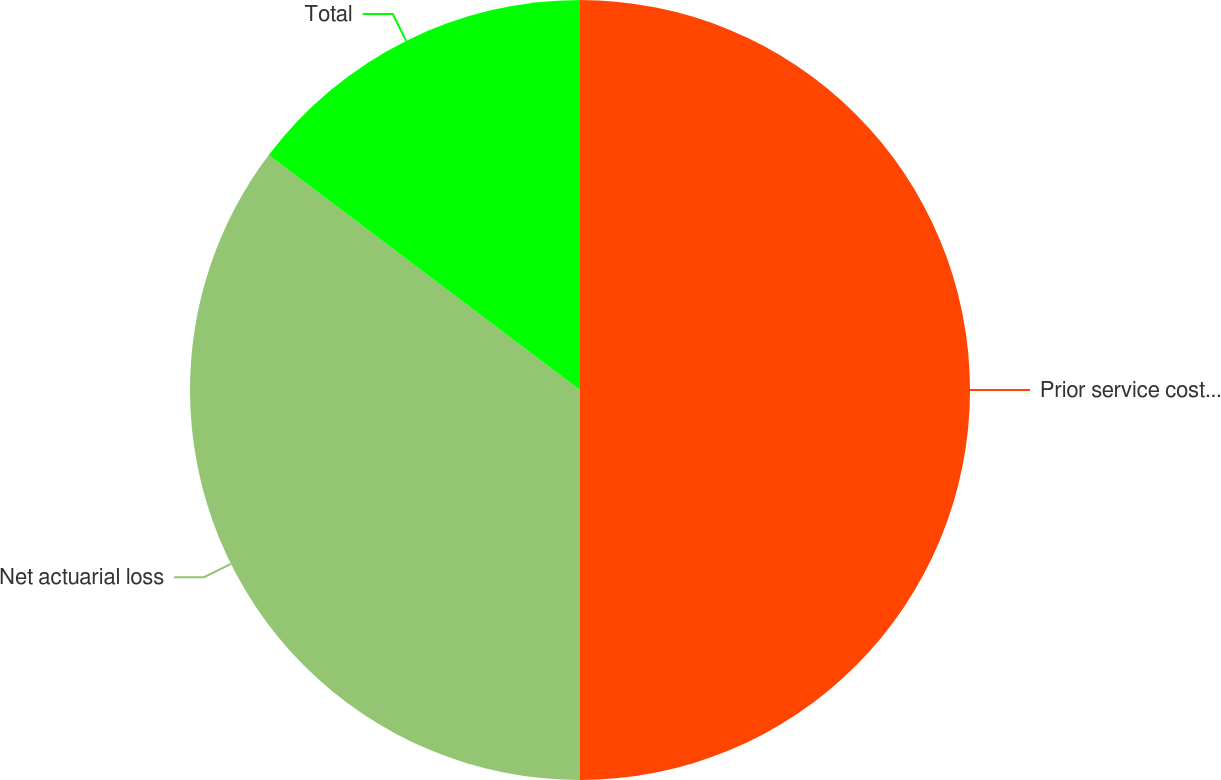Convert chart. <chart><loc_0><loc_0><loc_500><loc_500><pie_chart><fcel>Prior service cost/(benefit)<fcel>Net actuarial loss<fcel>Total<nl><fcel>50.0%<fcel>35.29%<fcel>14.71%<nl></chart> 